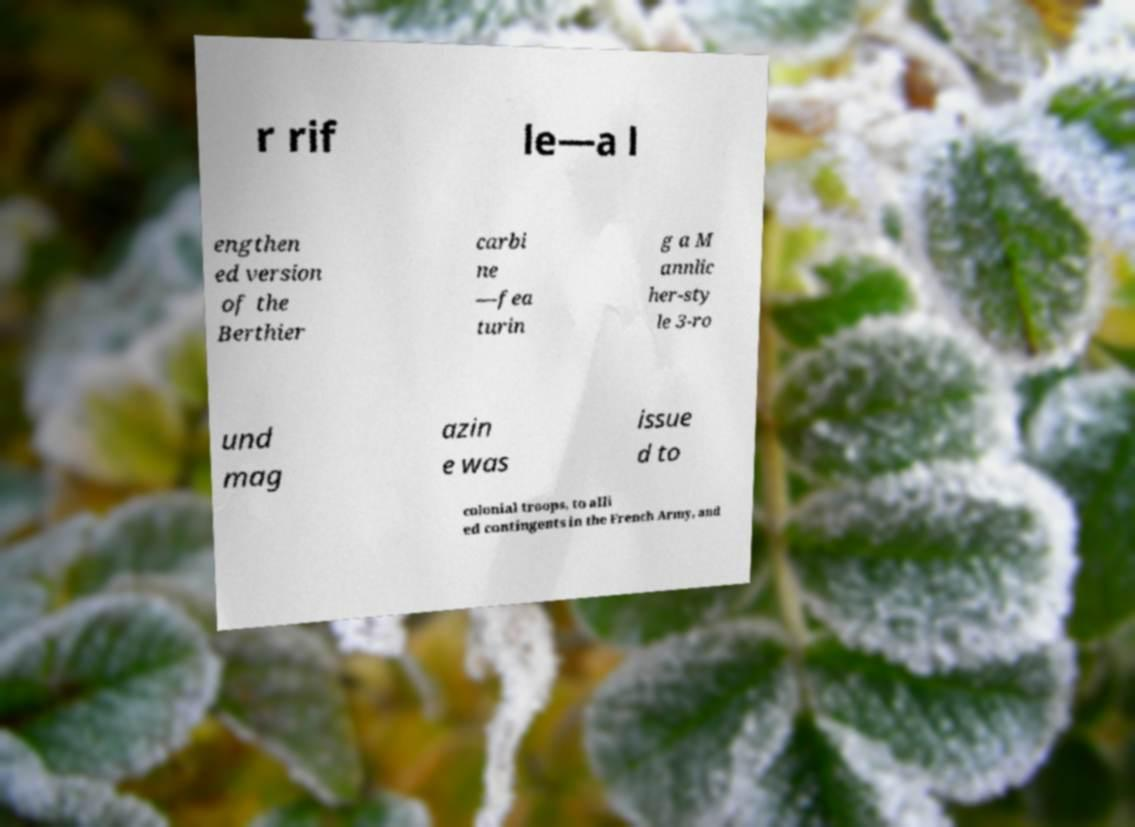Can you read and provide the text displayed in the image?This photo seems to have some interesting text. Can you extract and type it out for me? r rif le—a l engthen ed version of the Berthier carbi ne —fea turin g a M annlic her-sty le 3-ro und mag azin e was issue d to colonial troops, to alli ed contingents in the French Army, and 